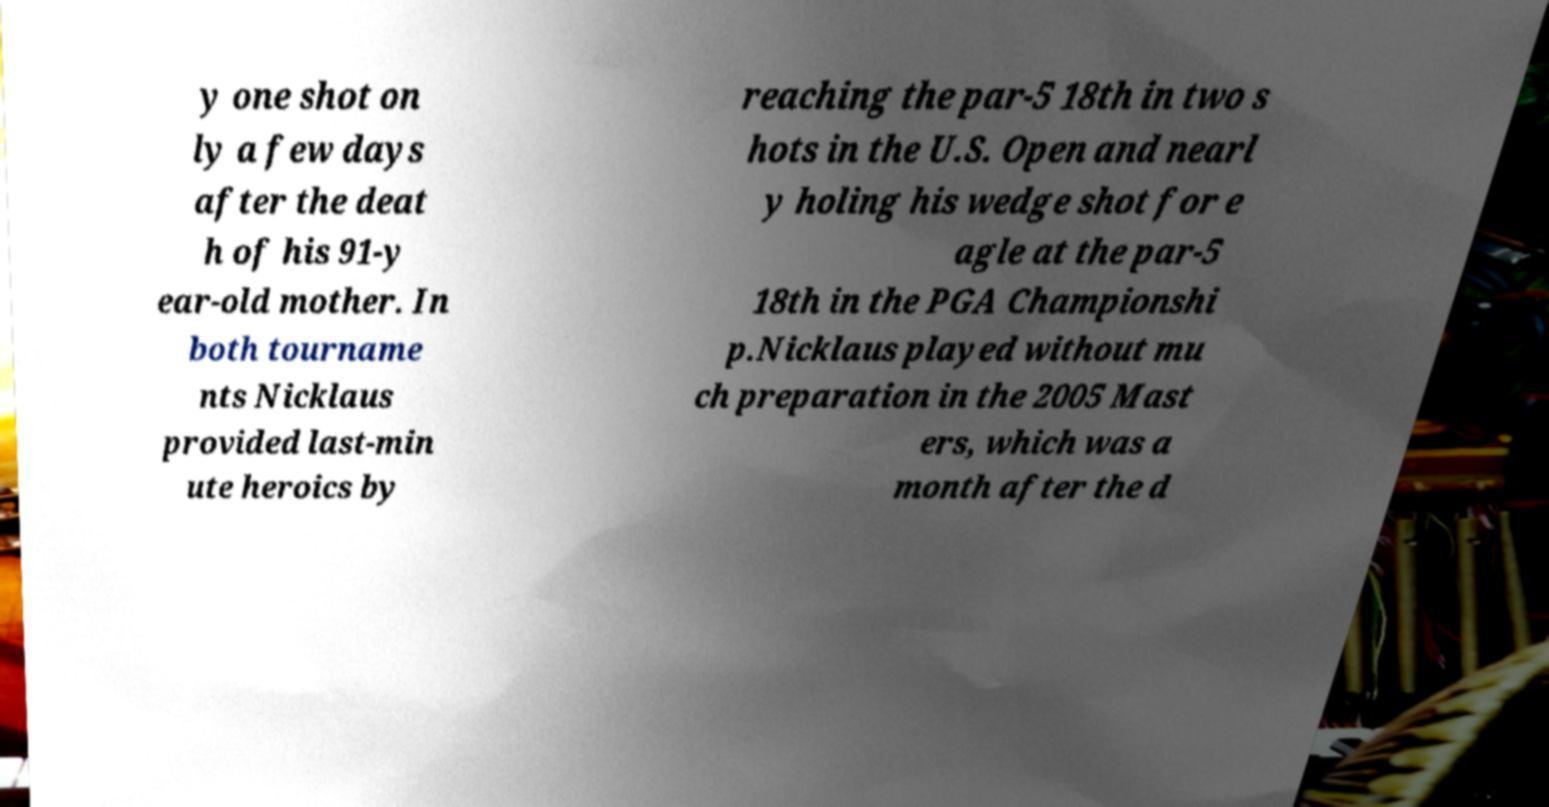Can you accurately transcribe the text from the provided image for me? y one shot on ly a few days after the deat h of his 91-y ear-old mother. In both tourname nts Nicklaus provided last-min ute heroics by reaching the par-5 18th in two s hots in the U.S. Open and nearl y holing his wedge shot for e agle at the par-5 18th in the PGA Championshi p.Nicklaus played without mu ch preparation in the 2005 Mast ers, which was a month after the d 